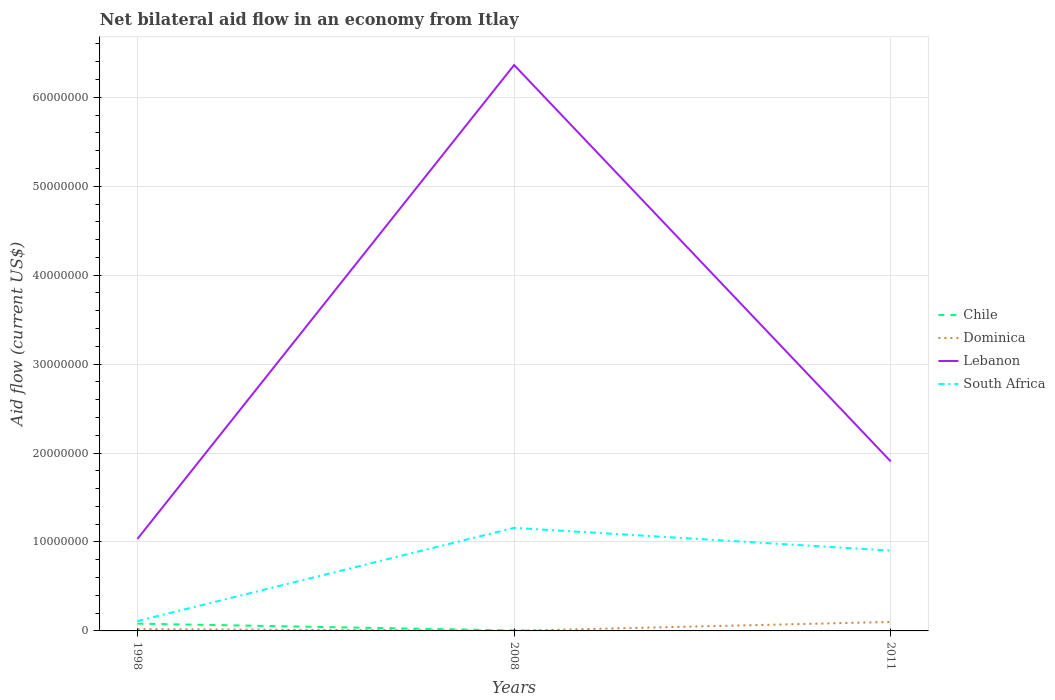How many different coloured lines are there?
Offer a terse response. 4. Is the number of lines equal to the number of legend labels?
Your answer should be very brief. No. Across all years, what is the maximum net bilateral aid flow in Chile?
Your answer should be compact. 0. What is the total net bilateral aid flow in Dominica in the graph?
Your response must be concise. -9.90e+05. What is the difference between the highest and the second highest net bilateral aid flow in Chile?
Your answer should be compact. 8.20e+05. Is the net bilateral aid flow in Dominica strictly greater than the net bilateral aid flow in Chile over the years?
Provide a succinct answer. No. Does the graph contain grids?
Offer a very short reply. Yes. Where does the legend appear in the graph?
Your response must be concise. Center right. How many legend labels are there?
Your response must be concise. 4. How are the legend labels stacked?
Provide a short and direct response. Vertical. What is the title of the graph?
Your response must be concise. Net bilateral aid flow in an economy from Itlay. What is the label or title of the Y-axis?
Make the answer very short. Aid flow (current US$). What is the Aid flow (current US$) in Chile in 1998?
Ensure brevity in your answer.  8.20e+05. What is the Aid flow (current US$) in Lebanon in 1998?
Provide a succinct answer. 1.04e+07. What is the Aid flow (current US$) in South Africa in 1998?
Your answer should be very brief. 1.11e+06. What is the Aid flow (current US$) of Chile in 2008?
Offer a terse response. 5.00e+04. What is the Aid flow (current US$) of Dominica in 2008?
Provide a short and direct response. 2.00e+04. What is the Aid flow (current US$) in Lebanon in 2008?
Provide a short and direct response. 6.36e+07. What is the Aid flow (current US$) in South Africa in 2008?
Provide a succinct answer. 1.16e+07. What is the Aid flow (current US$) of Chile in 2011?
Ensure brevity in your answer.  0. What is the Aid flow (current US$) in Dominica in 2011?
Your answer should be compact. 1.01e+06. What is the Aid flow (current US$) of Lebanon in 2011?
Provide a succinct answer. 1.91e+07. What is the Aid flow (current US$) of South Africa in 2011?
Provide a succinct answer. 9.03e+06. Across all years, what is the maximum Aid flow (current US$) in Chile?
Give a very brief answer. 8.20e+05. Across all years, what is the maximum Aid flow (current US$) in Dominica?
Keep it short and to the point. 1.01e+06. Across all years, what is the maximum Aid flow (current US$) in Lebanon?
Keep it short and to the point. 6.36e+07. Across all years, what is the maximum Aid flow (current US$) in South Africa?
Your answer should be very brief. 1.16e+07. Across all years, what is the minimum Aid flow (current US$) of Chile?
Provide a succinct answer. 0. Across all years, what is the minimum Aid flow (current US$) of Dominica?
Keep it short and to the point. 2.00e+04. Across all years, what is the minimum Aid flow (current US$) in Lebanon?
Provide a succinct answer. 1.04e+07. Across all years, what is the minimum Aid flow (current US$) in South Africa?
Provide a short and direct response. 1.11e+06. What is the total Aid flow (current US$) of Chile in the graph?
Your answer should be compact. 8.70e+05. What is the total Aid flow (current US$) in Dominica in the graph?
Keep it short and to the point. 1.23e+06. What is the total Aid flow (current US$) in Lebanon in the graph?
Offer a terse response. 9.30e+07. What is the total Aid flow (current US$) of South Africa in the graph?
Your answer should be compact. 2.17e+07. What is the difference between the Aid flow (current US$) of Chile in 1998 and that in 2008?
Provide a short and direct response. 7.70e+05. What is the difference between the Aid flow (current US$) in Dominica in 1998 and that in 2008?
Your response must be concise. 1.80e+05. What is the difference between the Aid flow (current US$) in Lebanon in 1998 and that in 2008?
Offer a very short reply. -5.33e+07. What is the difference between the Aid flow (current US$) in South Africa in 1998 and that in 2008?
Give a very brief answer. -1.05e+07. What is the difference between the Aid flow (current US$) in Dominica in 1998 and that in 2011?
Provide a short and direct response. -8.10e+05. What is the difference between the Aid flow (current US$) in Lebanon in 1998 and that in 2011?
Make the answer very short. -8.71e+06. What is the difference between the Aid flow (current US$) in South Africa in 1998 and that in 2011?
Provide a short and direct response. -7.92e+06. What is the difference between the Aid flow (current US$) of Dominica in 2008 and that in 2011?
Your answer should be compact. -9.90e+05. What is the difference between the Aid flow (current US$) of Lebanon in 2008 and that in 2011?
Offer a terse response. 4.46e+07. What is the difference between the Aid flow (current US$) in South Africa in 2008 and that in 2011?
Offer a very short reply. 2.56e+06. What is the difference between the Aid flow (current US$) in Chile in 1998 and the Aid flow (current US$) in Dominica in 2008?
Your answer should be very brief. 8.00e+05. What is the difference between the Aid flow (current US$) of Chile in 1998 and the Aid flow (current US$) of Lebanon in 2008?
Your response must be concise. -6.28e+07. What is the difference between the Aid flow (current US$) in Chile in 1998 and the Aid flow (current US$) in South Africa in 2008?
Your answer should be compact. -1.08e+07. What is the difference between the Aid flow (current US$) of Dominica in 1998 and the Aid flow (current US$) of Lebanon in 2008?
Provide a succinct answer. -6.34e+07. What is the difference between the Aid flow (current US$) in Dominica in 1998 and the Aid flow (current US$) in South Africa in 2008?
Give a very brief answer. -1.14e+07. What is the difference between the Aid flow (current US$) of Lebanon in 1998 and the Aid flow (current US$) of South Africa in 2008?
Give a very brief answer. -1.24e+06. What is the difference between the Aid flow (current US$) in Chile in 1998 and the Aid flow (current US$) in Lebanon in 2011?
Provide a short and direct response. -1.82e+07. What is the difference between the Aid flow (current US$) in Chile in 1998 and the Aid flow (current US$) in South Africa in 2011?
Provide a short and direct response. -8.21e+06. What is the difference between the Aid flow (current US$) of Dominica in 1998 and the Aid flow (current US$) of Lebanon in 2011?
Ensure brevity in your answer.  -1.89e+07. What is the difference between the Aid flow (current US$) in Dominica in 1998 and the Aid flow (current US$) in South Africa in 2011?
Offer a very short reply. -8.83e+06. What is the difference between the Aid flow (current US$) in Lebanon in 1998 and the Aid flow (current US$) in South Africa in 2011?
Make the answer very short. 1.32e+06. What is the difference between the Aid flow (current US$) of Chile in 2008 and the Aid flow (current US$) of Dominica in 2011?
Your answer should be compact. -9.60e+05. What is the difference between the Aid flow (current US$) in Chile in 2008 and the Aid flow (current US$) in Lebanon in 2011?
Offer a terse response. -1.90e+07. What is the difference between the Aid flow (current US$) of Chile in 2008 and the Aid flow (current US$) of South Africa in 2011?
Make the answer very short. -8.98e+06. What is the difference between the Aid flow (current US$) in Dominica in 2008 and the Aid flow (current US$) in Lebanon in 2011?
Give a very brief answer. -1.90e+07. What is the difference between the Aid flow (current US$) in Dominica in 2008 and the Aid flow (current US$) in South Africa in 2011?
Your response must be concise. -9.01e+06. What is the difference between the Aid flow (current US$) in Lebanon in 2008 and the Aid flow (current US$) in South Africa in 2011?
Keep it short and to the point. 5.46e+07. What is the average Aid flow (current US$) in Dominica per year?
Offer a very short reply. 4.10e+05. What is the average Aid flow (current US$) of Lebanon per year?
Provide a short and direct response. 3.10e+07. What is the average Aid flow (current US$) of South Africa per year?
Your response must be concise. 7.24e+06. In the year 1998, what is the difference between the Aid flow (current US$) in Chile and Aid flow (current US$) in Dominica?
Ensure brevity in your answer.  6.20e+05. In the year 1998, what is the difference between the Aid flow (current US$) of Chile and Aid flow (current US$) of Lebanon?
Your answer should be compact. -9.53e+06. In the year 1998, what is the difference between the Aid flow (current US$) in Chile and Aid flow (current US$) in South Africa?
Your answer should be compact. -2.90e+05. In the year 1998, what is the difference between the Aid flow (current US$) in Dominica and Aid flow (current US$) in Lebanon?
Provide a short and direct response. -1.02e+07. In the year 1998, what is the difference between the Aid flow (current US$) in Dominica and Aid flow (current US$) in South Africa?
Keep it short and to the point. -9.10e+05. In the year 1998, what is the difference between the Aid flow (current US$) in Lebanon and Aid flow (current US$) in South Africa?
Your response must be concise. 9.24e+06. In the year 2008, what is the difference between the Aid flow (current US$) in Chile and Aid flow (current US$) in Dominica?
Provide a short and direct response. 3.00e+04. In the year 2008, what is the difference between the Aid flow (current US$) in Chile and Aid flow (current US$) in Lebanon?
Your response must be concise. -6.36e+07. In the year 2008, what is the difference between the Aid flow (current US$) of Chile and Aid flow (current US$) of South Africa?
Your answer should be compact. -1.15e+07. In the year 2008, what is the difference between the Aid flow (current US$) in Dominica and Aid flow (current US$) in Lebanon?
Provide a succinct answer. -6.36e+07. In the year 2008, what is the difference between the Aid flow (current US$) of Dominica and Aid flow (current US$) of South Africa?
Offer a very short reply. -1.16e+07. In the year 2008, what is the difference between the Aid flow (current US$) in Lebanon and Aid flow (current US$) in South Africa?
Your response must be concise. 5.20e+07. In the year 2011, what is the difference between the Aid flow (current US$) in Dominica and Aid flow (current US$) in Lebanon?
Your response must be concise. -1.80e+07. In the year 2011, what is the difference between the Aid flow (current US$) in Dominica and Aid flow (current US$) in South Africa?
Your answer should be very brief. -8.02e+06. In the year 2011, what is the difference between the Aid flow (current US$) of Lebanon and Aid flow (current US$) of South Africa?
Offer a terse response. 1.00e+07. What is the ratio of the Aid flow (current US$) in Dominica in 1998 to that in 2008?
Ensure brevity in your answer.  10. What is the ratio of the Aid flow (current US$) of Lebanon in 1998 to that in 2008?
Offer a terse response. 0.16. What is the ratio of the Aid flow (current US$) in South Africa in 1998 to that in 2008?
Make the answer very short. 0.1. What is the ratio of the Aid flow (current US$) of Dominica in 1998 to that in 2011?
Your response must be concise. 0.2. What is the ratio of the Aid flow (current US$) in Lebanon in 1998 to that in 2011?
Offer a terse response. 0.54. What is the ratio of the Aid flow (current US$) in South Africa in 1998 to that in 2011?
Your response must be concise. 0.12. What is the ratio of the Aid flow (current US$) of Dominica in 2008 to that in 2011?
Offer a terse response. 0.02. What is the ratio of the Aid flow (current US$) of Lebanon in 2008 to that in 2011?
Ensure brevity in your answer.  3.34. What is the ratio of the Aid flow (current US$) of South Africa in 2008 to that in 2011?
Offer a terse response. 1.28. What is the difference between the highest and the second highest Aid flow (current US$) of Dominica?
Offer a very short reply. 8.10e+05. What is the difference between the highest and the second highest Aid flow (current US$) in Lebanon?
Give a very brief answer. 4.46e+07. What is the difference between the highest and the second highest Aid flow (current US$) in South Africa?
Offer a terse response. 2.56e+06. What is the difference between the highest and the lowest Aid flow (current US$) of Chile?
Offer a very short reply. 8.20e+05. What is the difference between the highest and the lowest Aid flow (current US$) in Dominica?
Offer a very short reply. 9.90e+05. What is the difference between the highest and the lowest Aid flow (current US$) of Lebanon?
Make the answer very short. 5.33e+07. What is the difference between the highest and the lowest Aid flow (current US$) in South Africa?
Your answer should be very brief. 1.05e+07. 